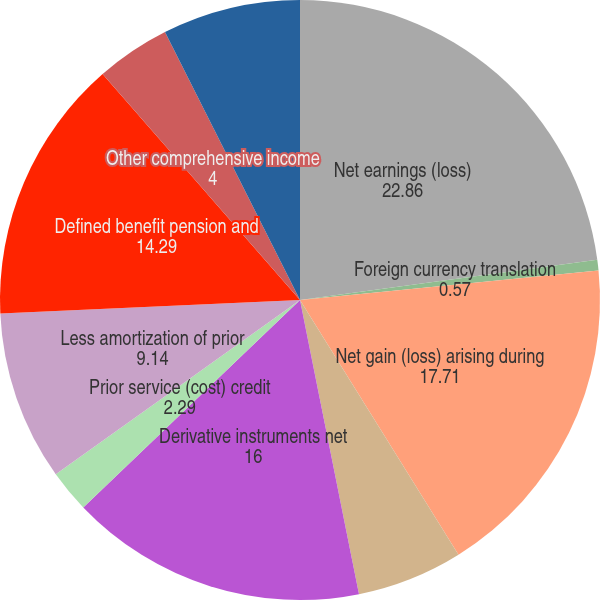Convert chart. <chart><loc_0><loc_0><loc_500><loc_500><pie_chart><fcel>Net earnings (loss)<fcel>Foreign currency translation<fcel>Net gain (loss) arising during<fcel>Less reclassification<fcel>Derivative instruments net<fcel>Prior service (cost) credit<fcel>Less amortization of prior<fcel>Defined benefit pension and<fcel>Other comprehensive income<fcel>Income tax benefit (expense)<nl><fcel>22.86%<fcel>0.57%<fcel>17.71%<fcel>5.71%<fcel>16.0%<fcel>2.29%<fcel>9.14%<fcel>14.29%<fcel>4.0%<fcel>7.43%<nl></chart> 